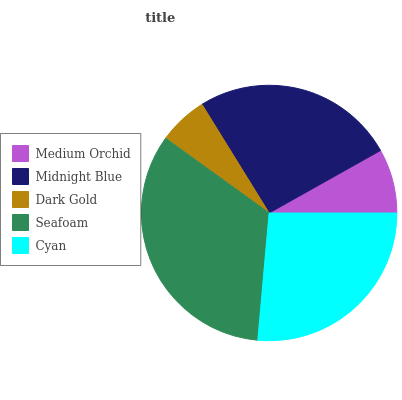Is Dark Gold the minimum?
Answer yes or no. Yes. Is Seafoam the maximum?
Answer yes or no. Yes. Is Midnight Blue the minimum?
Answer yes or no. No. Is Midnight Blue the maximum?
Answer yes or no. No. Is Midnight Blue greater than Medium Orchid?
Answer yes or no. Yes. Is Medium Orchid less than Midnight Blue?
Answer yes or no. Yes. Is Medium Orchid greater than Midnight Blue?
Answer yes or no. No. Is Midnight Blue less than Medium Orchid?
Answer yes or no. No. Is Midnight Blue the high median?
Answer yes or no. Yes. Is Midnight Blue the low median?
Answer yes or no. Yes. Is Medium Orchid the high median?
Answer yes or no. No. Is Dark Gold the low median?
Answer yes or no. No. 